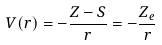Convert formula to latex. <formula><loc_0><loc_0><loc_500><loc_500>V ( r ) = - { \frac { Z - S } { r } } = - { \frac { Z _ { e } } { r } }</formula> 